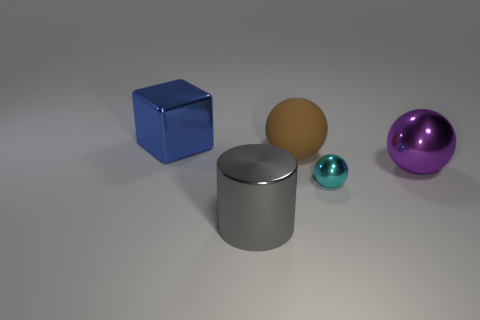Add 2 cubes. How many objects exist? 7 Subtract all balls. How many objects are left? 2 Add 5 big shiny objects. How many big shiny objects exist? 8 Subtract 1 blue cubes. How many objects are left? 4 Subtract all large brown matte things. Subtract all big blue shiny cubes. How many objects are left? 3 Add 1 big gray metal things. How many big gray metal things are left? 2 